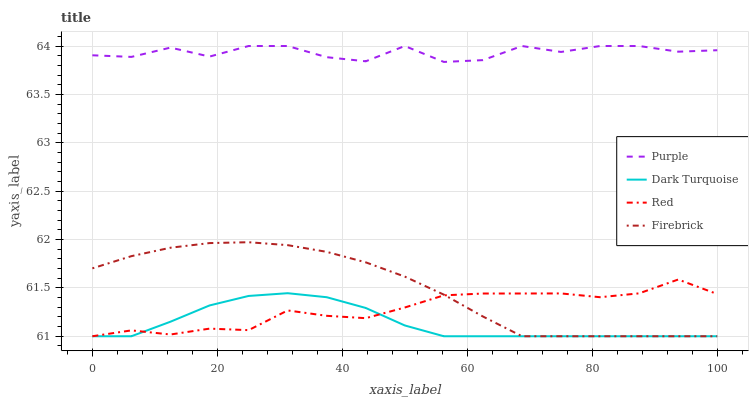Does Dark Turquoise have the minimum area under the curve?
Answer yes or no. Yes. Does Purple have the maximum area under the curve?
Answer yes or no. Yes. Does Firebrick have the minimum area under the curve?
Answer yes or no. No. Does Firebrick have the maximum area under the curve?
Answer yes or no. No. Is Firebrick the smoothest?
Answer yes or no. Yes. Is Purple the roughest?
Answer yes or no. Yes. Is Dark Turquoise the smoothest?
Answer yes or no. No. Is Dark Turquoise the roughest?
Answer yes or no. No. Does Dark Turquoise have the lowest value?
Answer yes or no. Yes. Does Purple have the highest value?
Answer yes or no. Yes. Does Firebrick have the highest value?
Answer yes or no. No. Is Red less than Purple?
Answer yes or no. Yes. Is Purple greater than Firebrick?
Answer yes or no. Yes. Does Dark Turquoise intersect Red?
Answer yes or no. Yes. Is Dark Turquoise less than Red?
Answer yes or no. No. Is Dark Turquoise greater than Red?
Answer yes or no. No. Does Red intersect Purple?
Answer yes or no. No. 